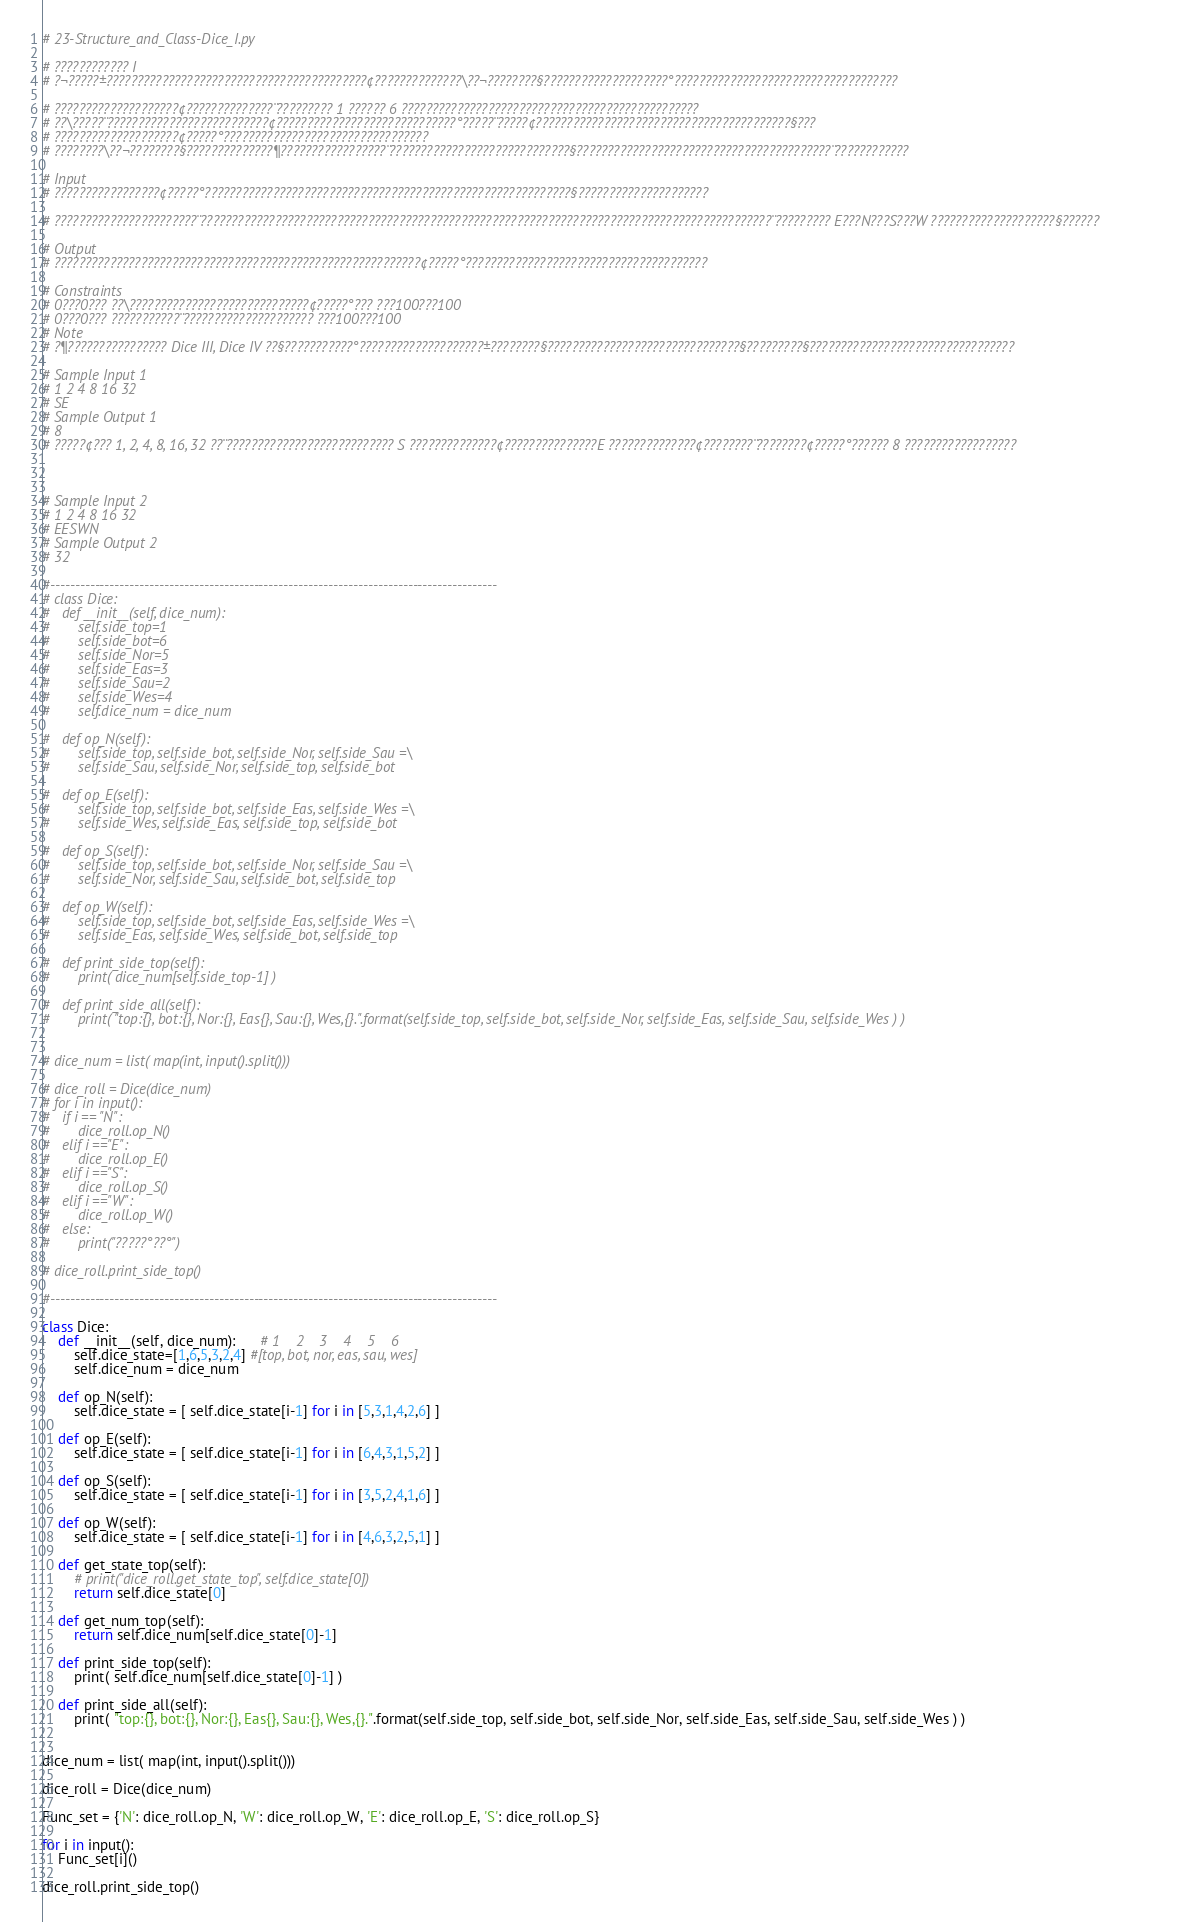Convert code to text. <code><loc_0><loc_0><loc_500><loc_500><_Python_># 23-Structure_and_Class-Dice_I.py

# ???????????? I
# ?¬?????±??????????????????????????????????????????¢??????????????\??¬????????§????????????????????°????????????????????????????????????

# ????????????????????¢??????????????¨????????? 1 ?????? 6 ????????????????????????????????????????????????
# ??\?????¨??????????????????????????¢?????????????????????????????°?????¨?????¢?????????????????????????????????????????§???
# ????????????????????¢?????°?????????????????????????????????
# ????????\??¬????????§??????????????¶?????????????????¨?????????????????????????????§?????????????????????????????????????????¨????????????

# Input
# ?????????????????¢?????°???????????????????????????????????????????????????????????§?????????????????????

# ???????????????????????¨????????????????????????????????????????????????????????????????????????????????????????????¨????????? E???N???S???W ????????????????????§??????

# Output
# ???????????????????????????????????????????????????????????¢?????°???????????????????????????????????????

# Constraints
# 0???0??? ??\?????????????????????????????¢?????°??? ???100???100
# 0???0??? ???????????¨????????????????????? ???100???100
# Note
# ?¶???????????????? Dice III, Dice IV ??§???????????°????????????????????±????????§???????????????????????????????§?????????§?????????????????????????????????

# Sample Input 1
# 1 2 4 8 16 32
# SE
# Sample Output 1
# 8
# ?????¢??? 1, 2, 4, 8, 16, 32 ??¨??????????????????????????? S ??????????????¢???????????????E ??????????????¢????????¨????????¢?????°?????? 8 ??????????????????



# Sample Input 2
# 1 2 4 8 16 32
# EESWN
# Sample Output 2
# 32

#------------------------------------------------------------------------------------------
# class Dice:
# 	def __init__(self, dice_num):
# 		self.side_top=1
# 		self.side_bot=6
# 		self.side_Nor=5
# 		self.side_Eas=3
# 		self.side_Sau=2
# 		self.side_Wes=4
# 		self.dice_num = dice_num

# 	def op_N(self):
# 		self.side_top, self.side_bot, self.side_Nor, self.side_Sau =\
# 		self.side_Sau, self.side_Nor, self.side_top, self.side_bot

# 	def op_E(self):
# 		self.side_top, self.side_bot, self.side_Eas, self.side_Wes =\
# 		self.side_Wes, self.side_Eas, self.side_top, self.side_bot

# 	def op_S(self):
# 		self.side_top, self.side_bot, self.side_Nor, self.side_Sau =\
# 		self.side_Nor, self.side_Sau, self.side_bot, self.side_top

# 	def op_W(self):
# 		self.side_top, self.side_bot, self.side_Eas, self.side_Wes =\
# 		self.side_Eas, self.side_Wes, self.side_bot, self.side_top

# 	def print_side_top(self):
# 		print( dice_num[self.side_top-1] )

# 	def print_side_all(self):
# 		print( "top:{}, bot:{}, Nor:{}, Eas{}, Sau:{}, Wes,{}.".format(self.side_top, self.side_bot, self.side_Nor, self.side_Eas, self.side_Sau, self.side_Wes ) )


# dice_num = list( map(int, input().split()))

# dice_roll = Dice(dice_num) 
# for i in input():
# 	if i == "N":
# 		dice_roll.op_N()
# 	elif i =="E":
# 		dice_roll.op_E()
# 	elif i =="S":
# 		dice_roll.op_S()
# 	elif i =="W":
# 		dice_roll.op_W()
# 	else:
# 		print("?????°??°")

# dice_roll.print_side_top()

#------------------------------------------------------------------------------------------

class Dice:
	def __init__(self, dice_num):	  # 1    2    3    4    5    6
		self.dice_state=[1,6,5,3,2,4] #[top, bot, nor, eas, sau, wes]
		self.dice_num = dice_num

	def op_N(self):
		self.dice_state = [ self.dice_state[i-1] for i in [5,3,1,4,2,6] ]

	def op_E(self):
		self.dice_state = [ self.dice_state[i-1] for i in [6,4,3,1,5,2] ]

	def op_S(self):
		self.dice_state = [ self.dice_state[i-1] for i in [3,5,2,4,1,6] ]

	def op_W(self):
		self.dice_state = [ self.dice_state[i-1] for i in [4,6,3,2,5,1] ]

	def get_state_top(self):
		# print("dice_roll.get_state_top", self.dice_state[0])
		return self.dice_state[0]

	def get_num_top(self):
		return self.dice_num[self.dice_state[0]-1]

	def print_side_top(self):
		print( self.dice_num[self.dice_state[0]-1] )

	def print_side_all(self):
		print( "top:{}, bot:{}, Nor:{}, Eas{}, Sau:{}, Wes,{}.".format(self.side_top, self.side_bot, self.side_Nor, self.side_Eas, self.side_Sau, self.side_Wes ) )


dice_num = list( map(int, input().split()))

dice_roll = Dice(dice_num) 

Func_set = {'N': dice_roll.op_N, 'W': dice_roll.op_W, 'E': dice_roll.op_E, 'S': dice_roll.op_S}

for i in input():
	Func_set[i]()

dice_roll.print_side_top()</code> 